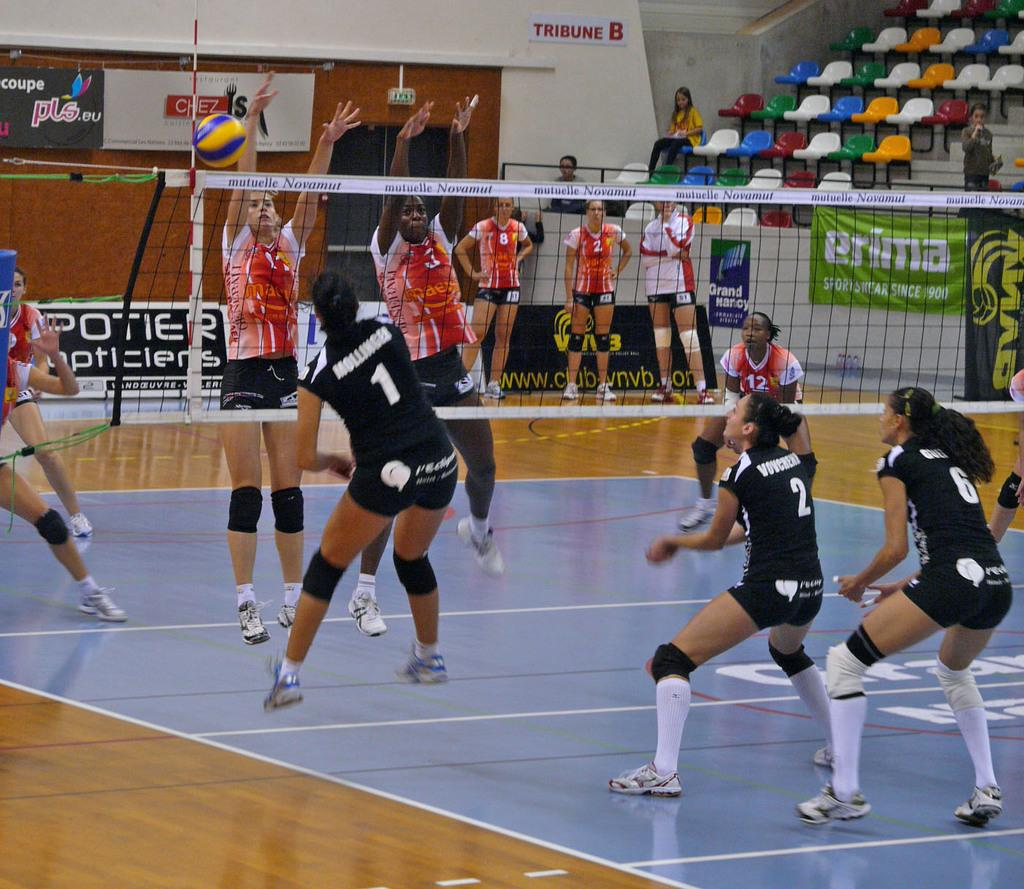Provide a one-sentence caption for the provided image. a game of volleyball between girls with one of the adverts saying Prima on it. 